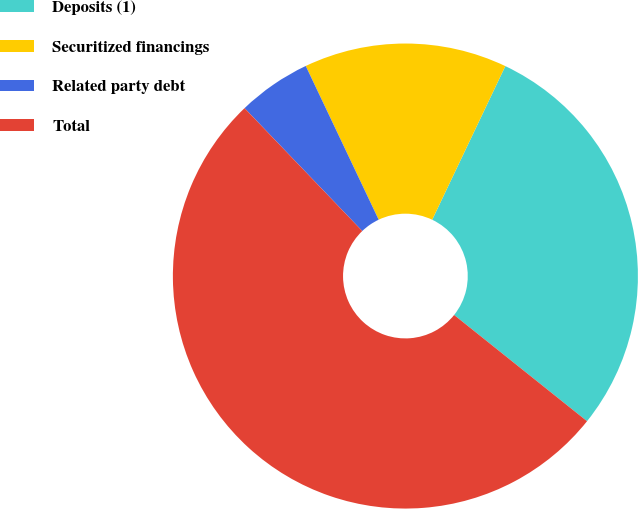Convert chart. <chart><loc_0><loc_0><loc_500><loc_500><pie_chart><fcel>Deposits (1)<fcel>Securitized financings<fcel>Related party debt<fcel>Total<nl><fcel>28.66%<fcel>14.12%<fcel>5.11%<fcel>52.11%<nl></chart> 